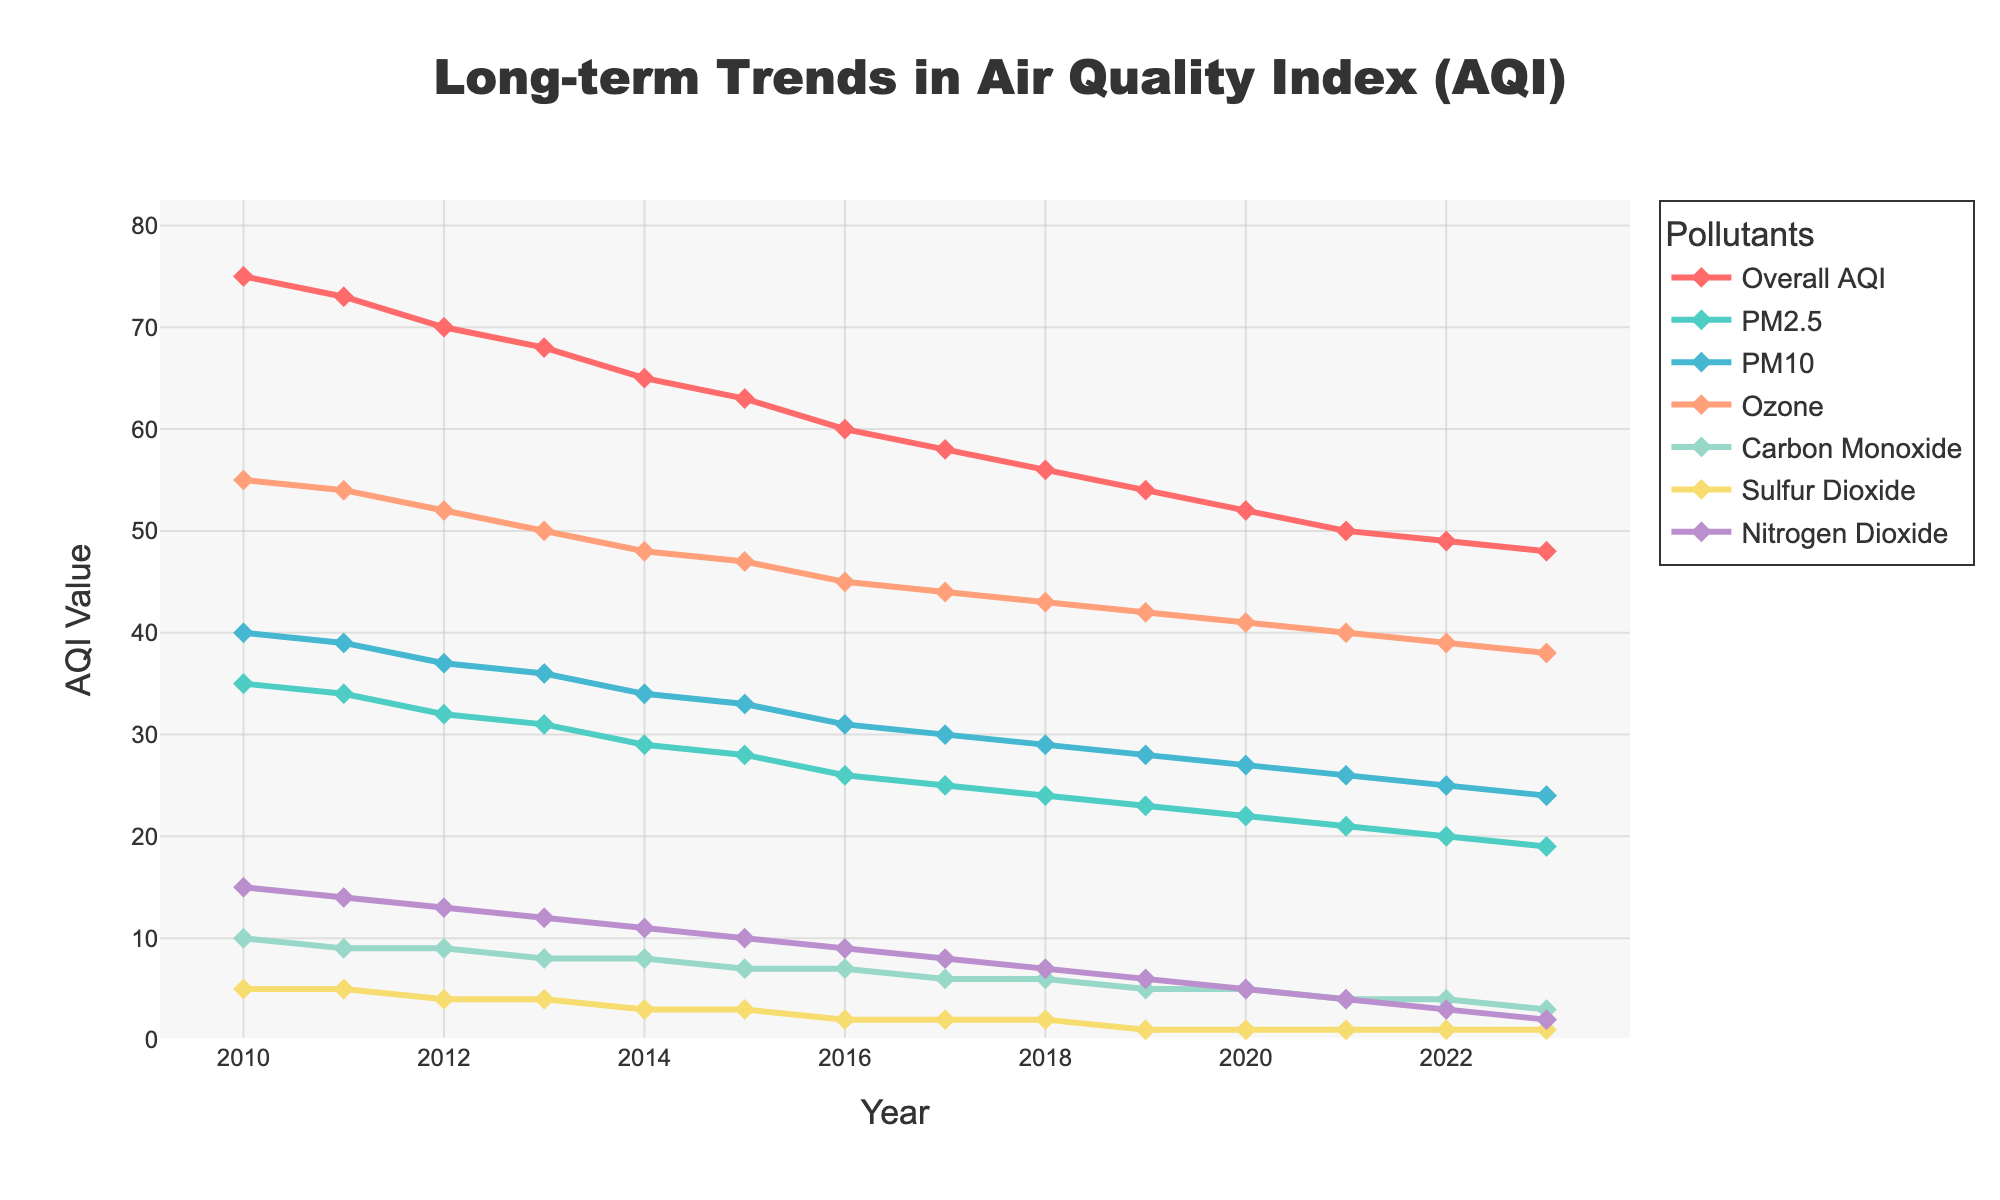How has the Overall AQI trended from 2010 to 2023? Observing the figure, the Overall AQI starts at 75 in 2010 and steadily decreases each year until it reaches 48 in 2023.
Answer: Decreasing Which pollutant shows the largest reduction from 2010 to 2023? Calculate the reduction for each pollutant: PM2.5 decreases from 35 to 19 (16 units), PM10 from 40 to 24 (16 units), Ozone from 55 to 38 (17 units), Carbon Monoxide from 10 to 3 (7 units), Sulfur Dioxide from 5 to 1 (4 units), Nitrogen Dioxide from 15 to 2 (13 units). Ozone shows the largest reduction of 17 units.
Answer: Ozone Between which consecutive years was the largest improvement in Overall AQI observed? Review the yearly decreases in Overall AQI: 2010-2011 (2), 2011-2012 (3), 2012-2013 (2), 2013-2014 (3), 2014-2015 (2), 2015-2016 (3), 2016-2017 (2), 2017-2018 (2), 2018-2019 (2), 2019-2020 (2), 2020-2021 (2), 2021-2022 (1), 2022-2023 (1). The largest improvement occurs between 2011-2012, 2013-2014, and 2015-2016 with a decrease of 3 units.
Answer: 2011-2012, 2013-2014, 2015-2016 In what year did Carbon Monoxide first reach its maximum reduction of 1 unit, and how does it compare to the other pollutants' reductions in the same year? Carbon Monoxide first reaches 1 unit in 2019. In 2019, PM2.5 decreases to 23, PM10 to 28, Ozone to 42, Sulfur Dioxide to 1, and Nitrogen Dioxide to 6. Comparing reductions in 2019: PM2.5 (12 units), PM10 (12 units), Ozone (13 units), Carbon Monoxide (9 units), Sulfur Dioxide (4 units), Nitrogen Dioxide (9 units).
Answer: 2019; PM2.5: 12, PM10: 12, Ozone: 13, CO: 9, SO₂: 4, NO₂: 9 Which pollutant had the smallest change in level from 2010 to 2023? Calculate the change from 2010 to 2023: PM2.5 reduces by 16 units, PM10 by 16 units, Ozone by 17 units, Carbon Monoxide by 7 units, Sulfur Dioxide by 4 units, Nitrogen Dioxide by 13 units. Sulfur Dioxide shows the smallest change with a reduction of 4 units.
Answer: Sulfur Dioxide 